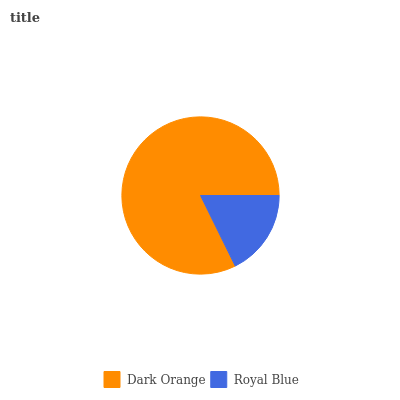Is Royal Blue the minimum?
Answer yes or no. Yes. Is Dark Orange the maximum?
Answer yes or no. Yes. Is Royal Blue the maximum?
Answer yes or no. No. Is Dark Orange greater than Royal Blue?
Answer yes or no. Yes. Is Royal Blue less than Dark Orange?
Answer yes or no. Yes. Is Royal Blue greater than Dark Orange?
Answer yes or no. No. Is Dark Orange less than Royal Blue?
Answer yes or no. No. Is Dark Orange the high median?
Answer yes or no. Yes. Is Royal Blue the low median?
Answer yes or no. Yes. Is Royal Blue the high median?
Answer yes or no. No. Is Dark Orange the low median?
Answer yes or no. No. 